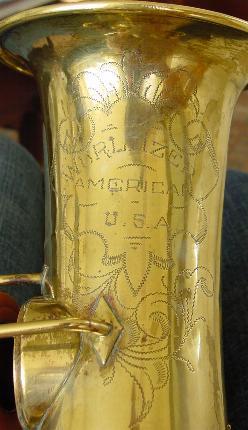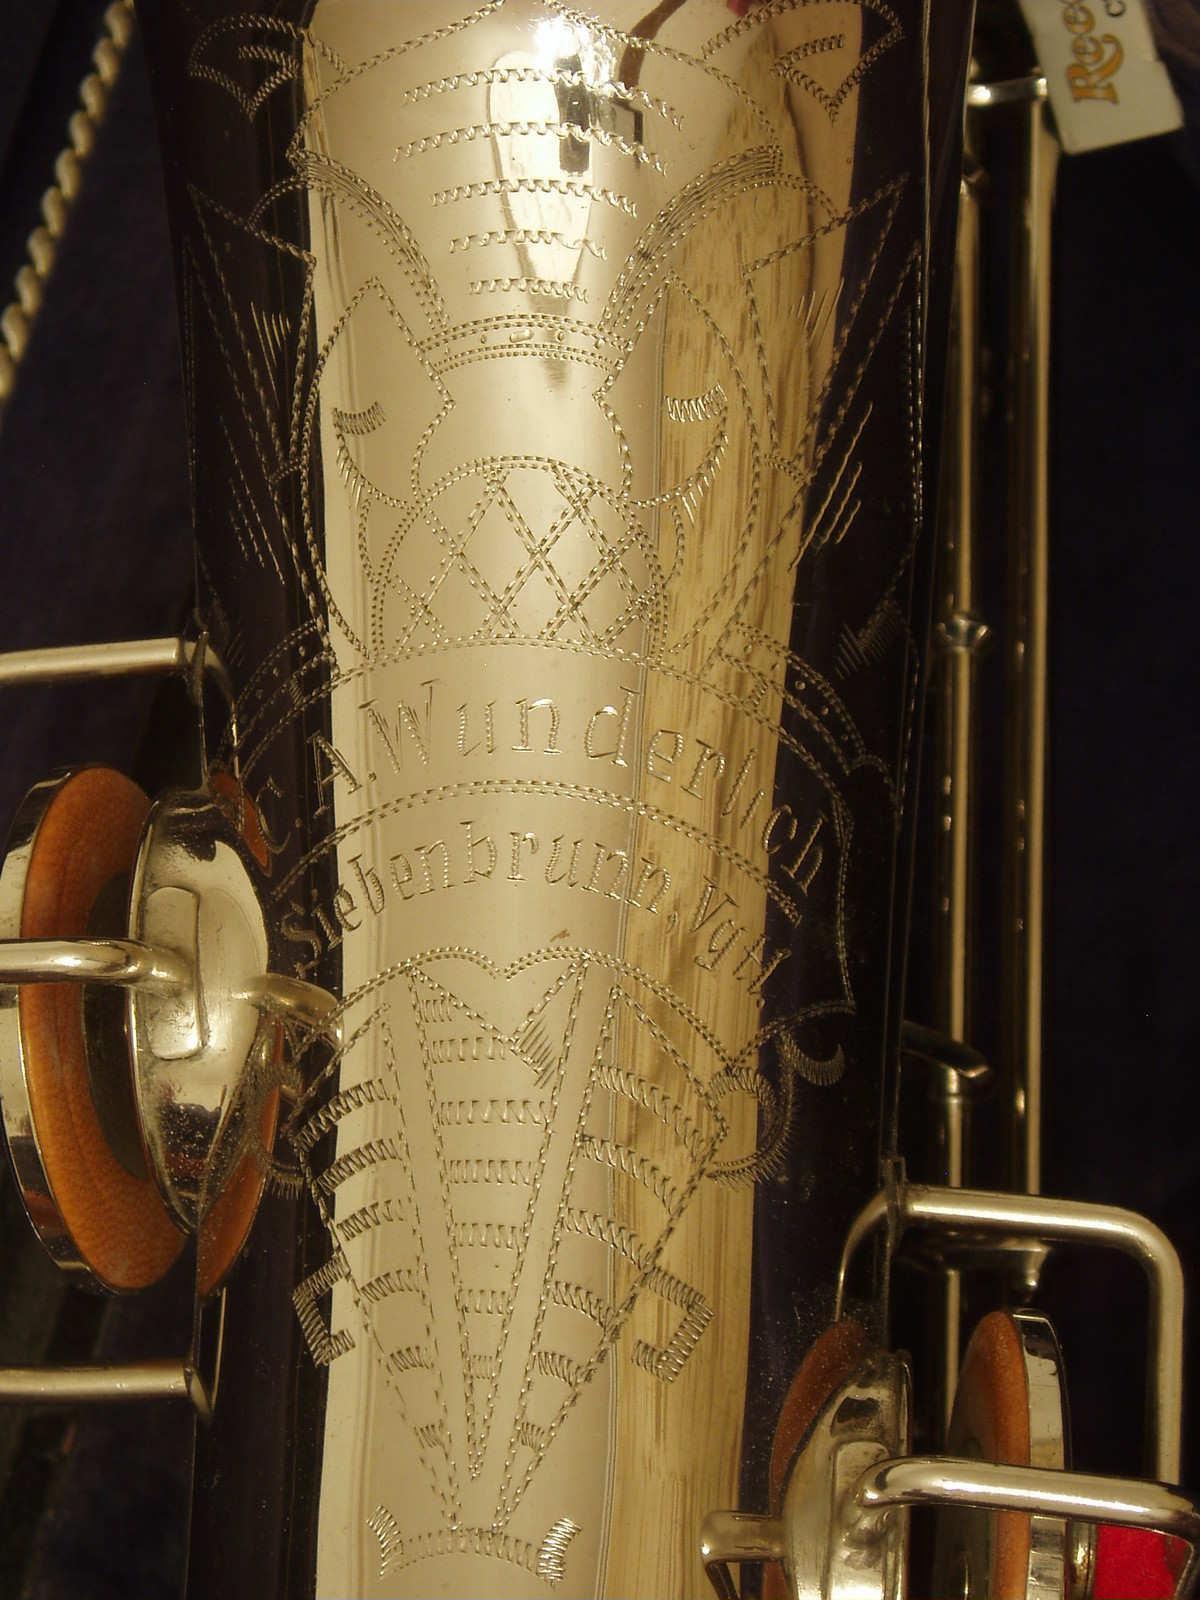The first image is the image on the left, the second image is the image on the right. For the images displayed, is the sentence "In at least one image, the close up picture reveals text that has been engraved into the saxophone." factually correct? Answer yes or no. Yes. 